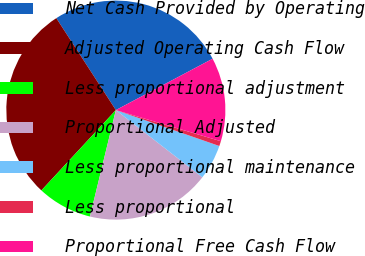Convert chart to OTSL. <chart><loc_0><loc_0><loc_500><loc_500><pie_chart><fcel>Net Cash Provided by Operating<fcel>Adjusted Operating Cash Flow<fcel>Less proportional adjustment<fcel>Proportional Adjusted<fcel>Less proportional maintenance<fcel>Less proportional<fcel>Proportional Free Cash Flow<nl><fcel>26.38%<fcel>28.95%<fcel>8.1%<fcel>18.28%<fcel>5.2%<fcel>0.73%<fcel>12.35%<nl></chart> 